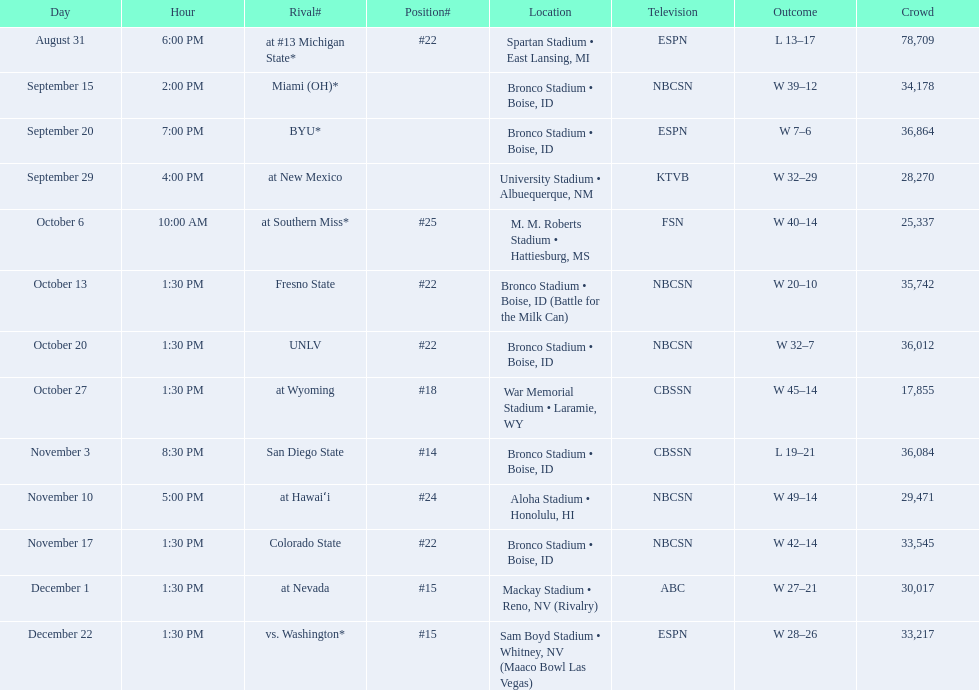What are the opponent teams of the 2012 boise state broncos football team? At #13 michigan state*, miami (oh)*, byu*, at new mexico, at southern miss*, fresno state, unlv, at wyoming, san diego state, at hawaiʻi, colorado state, at nevada, vs. washington*. How has the highest rank of these opponents? San Diego State. 